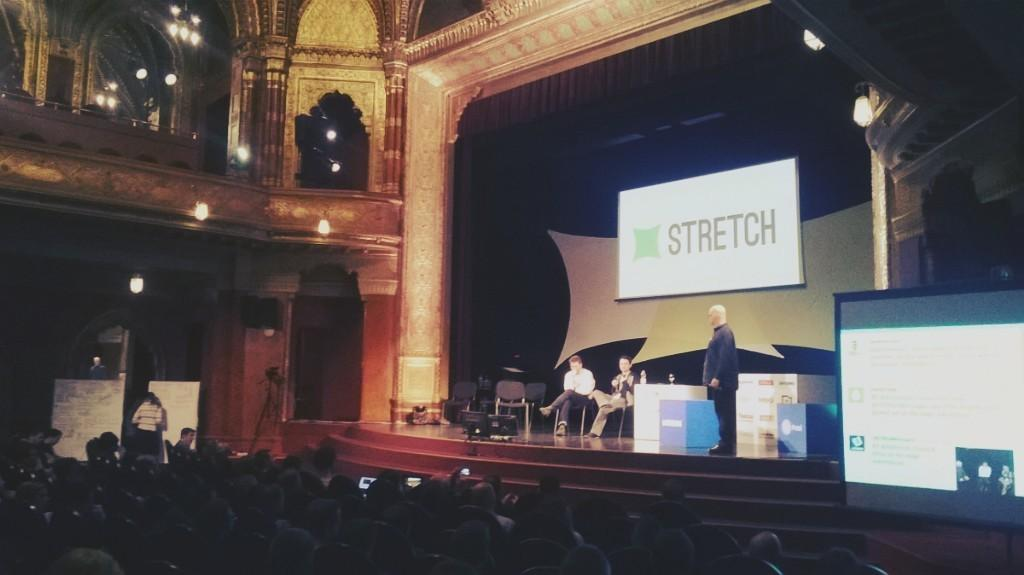<image>
Summarize the visual content of the image. The word "Stretch" stretches across a large screen above presenters on stage in a large theater. 